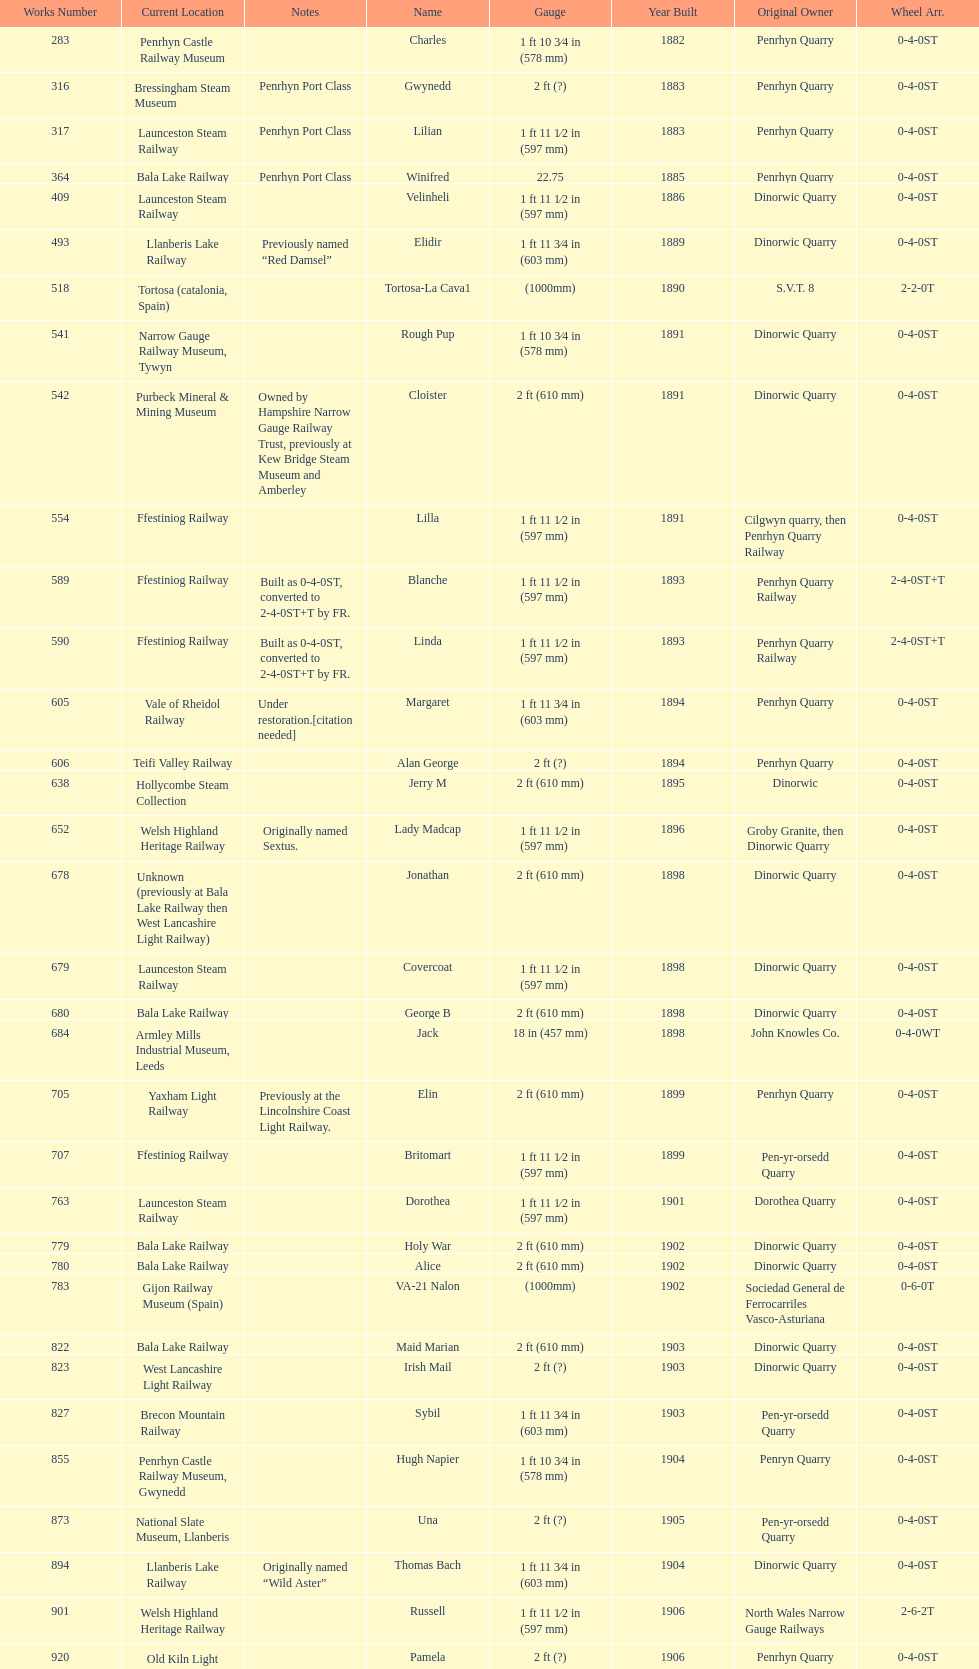Which works number had a larger gauge, 283 or 317? 317. 